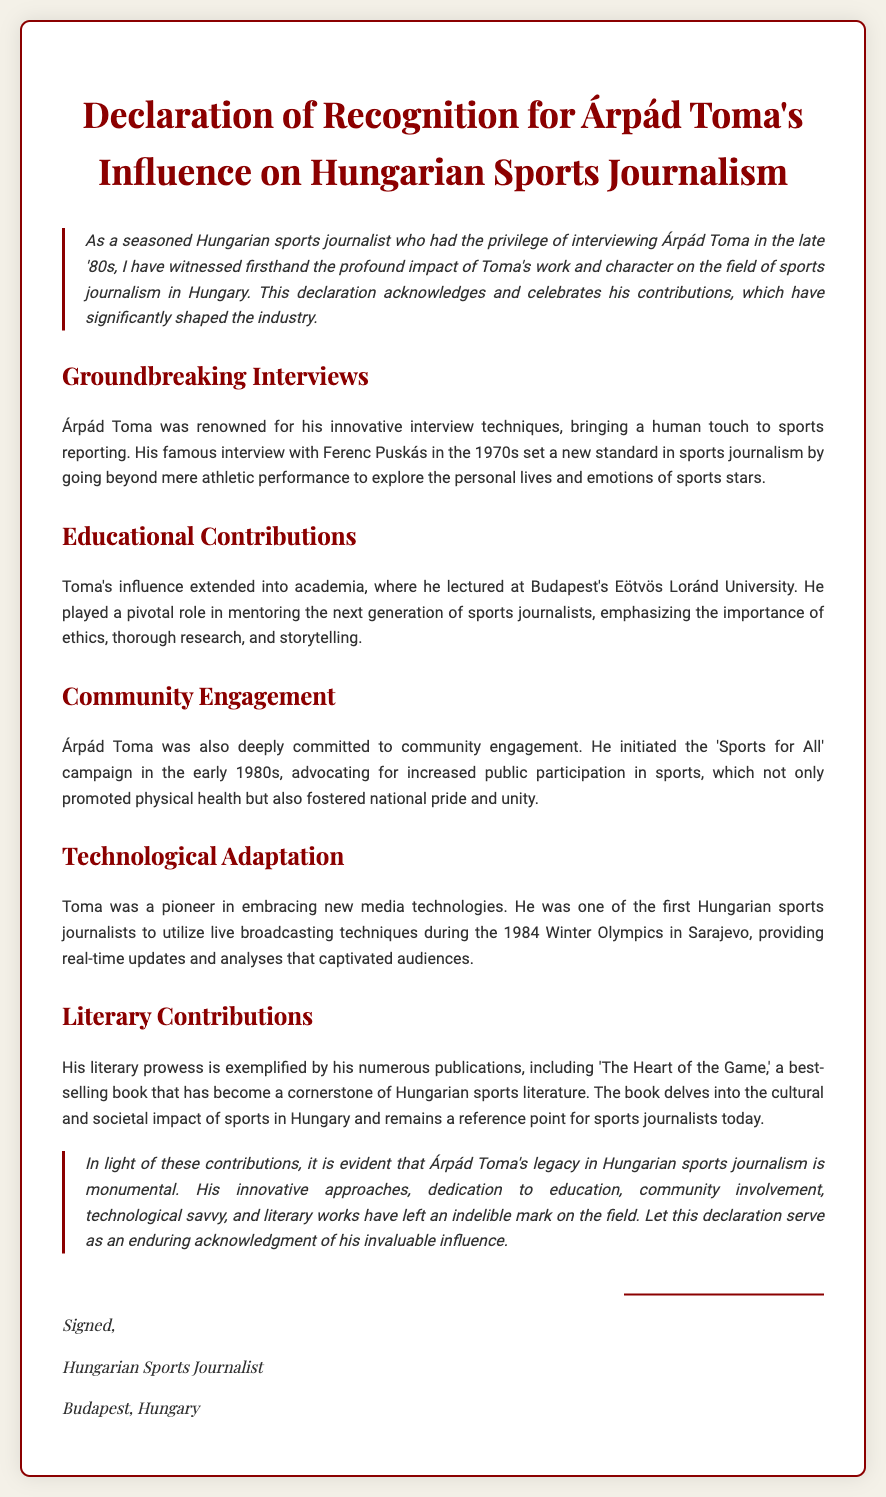What is the title of the document? The title of the document is explicitly stated at the top as "Declaration of Recognition for Árpád Toma's Influence on Hungarian Sports Journalism."
Answer: Declaration of Recognition for Árpád Toma's Influence on Hungarian Sports Journalism Who conducted the famous interview with Ferenc Puskás? The document mentions that Árpád Toma conducted the famous interview with Ferenc Puskás in the 1970s.
Answer: Árpád Toma What university did Toma lecture at? The document states that Toma lectured at Budapest's Eötvös Loránd University.
Answer: Eötvös Loránd University In what year did Toma utilize live broadcasting techniques during the Winter Olympics? The document indicates that Toma utilized live broadcasting techniques during the 1984 Winter Olympics in Sarajevo.
Answer: 1984 What campaign did Toma initiate in the early 1980s? The document refers to the 'Sports for All' campaign initiated by Toma in the early 1980s.
Answer: Sports for All What is the title of Toma's best-selling book? The document identifies the title of Toma's best-selling book as 'The Heart of the Game.'
Answer: The Heart of the Game What color is used for the main title text? The document describes the main title text color as #8b0000.
Answer: #8b0000 What is the main theme of Toma's literary contributions? The document explains that Toma's literary contributions focus on the cultural and societal impact of sports in Hungary.
Answer: Cultural and societal impact of sports in Hungary What type of document is this? The nature of the document is clarified in the introductory section as a recognition declaration.
Answer: Recognition declaration 